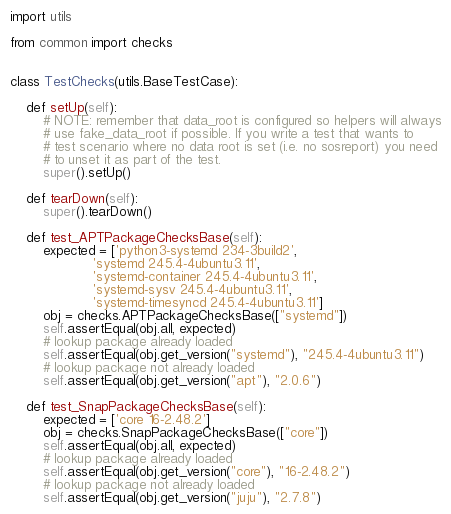Convert code to text. <code><loc_0><loc_0><loc_500><loc_500><_Python_>import utils

from common import checks


class TestChecks(utils.BaseTestCase):

    def setUp(self):
        # NOTE: remember that data_root is configured so helpers will always
        # use fake_data_root if possible. If you write a test that wants to
        # test scenario where no data root is set (i.e. no sosreport) you need
        # to unset it as part of the test.
        super().setUp()

    def tearDown(self):
        super().tearDown()

    def test_APTPackageChecksBase(self):
        expected = ['python3-systemd 234-3build2',
                    'systemd 245.4-4ubuntu3.11',
                    'systemd-container 245.4-4ubuntu3.11',
                    'systemd-sysv 245.4-4ubuntu3.11',
                    'systemd-timesyncd 245.4-4ubuntu3.11']
        obj = checks.APTPackageChecksBase(["systemd"])
        self.assertEqual(obj.all, expected)
        # lookup package already loaded
        self.assertEqual(obj.get_version("systemd"), "245.4-4ubuntu3.11")
        # lookup package not already loaded
        self.assertEqual(obj.get_version("apt"), "2.0.6")

    def test_SnapPackageChecksBase(self):
        expected = ['core 16-2.48.2']
        obj = checks.SnapPackageChecksBase(["core"])
        self.assertEqual(obj.all, expected)
        # lookup package already loaded
        self.assertEqual(obj.get_version("core"), "16-2.48.2")
        # lookup package not already loaded
        self.assertEqual(obj.get_version("juju"), "2.7.8")
</code> 